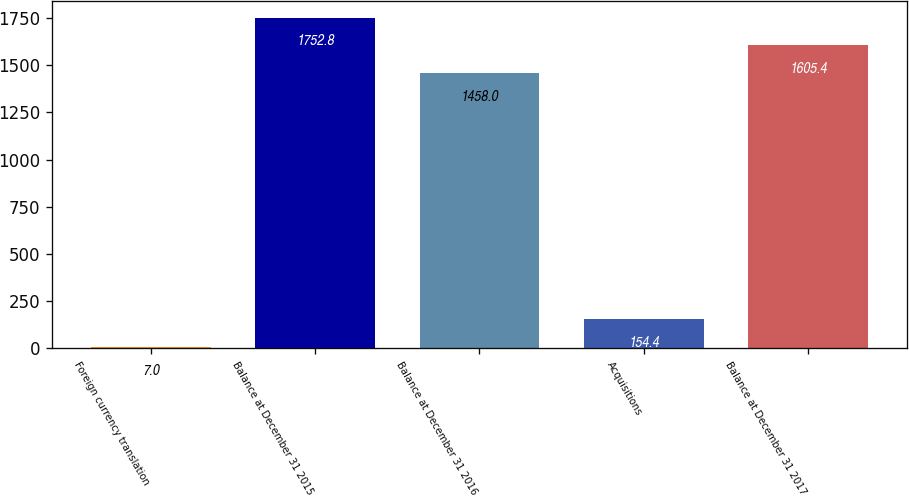Convert chart. <chart><loc_0><loc_0><loc_500><loc_500><bar_chart><fcel>Foreign currency translation<fcel>Balance at December 31 2015<fcel>Balance at December 31 2016<fcel>Acquisitions<fcel>Balance at December 31 2017<nl><fcel>7<fcel>1752.8<fcel>1458<fcel>154.4<fcel>1605.4<nl></chart> 